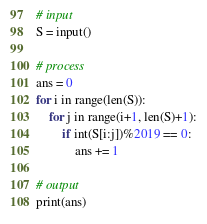Convert code to text. <code><loc_0><loc_0><loc_500><loc_500><_Python_># input
S = input()

# process
ans = 0
for i in range(len(S)):
    for j in range(i+1, len(S)+1):
        if int(S[i:j])%2019 == 0:
            ans += 1

# output
print(ans)
</code> 